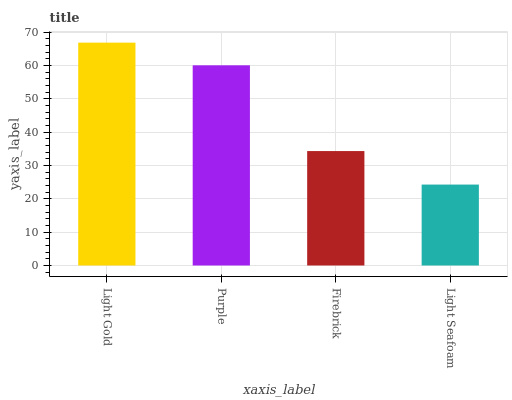Is Light Seafoam the minimum?
Answer yes or no. Yes. Is Light Gold the maximum?
Answer yes or no. Yes. Is Purple the minimum?
Answer yes or no. No. Is Purple the maximum?
Answer yes or no. No. Is Light Gold greater than Purple?
Answer yes or no. Yes. Is Purple less than Light Gold?
Answer yes or no. Yes. Is Purple greater than Light Gold?
Answer yes or no. No. Is Light Gold less than Purple?
Answer yes or no. No. Is Purple the high median?
Answer yes or no. Yes. Is Firebrick the low median?
Answer yes or no. Yes. Is Light Gold the high median?
Answer yes or no. No. Is Light Seafoam the low median?
Answer yes or no. No. 